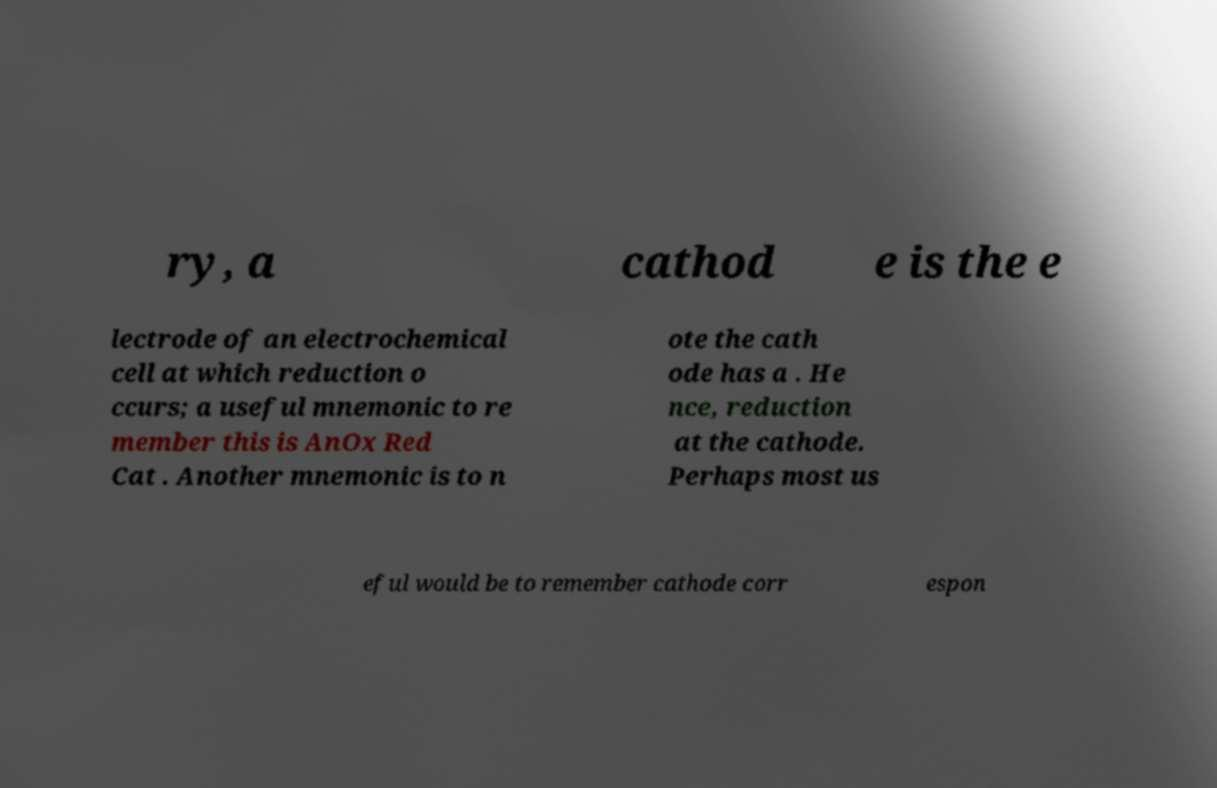What messages or text are displayed in this image? I need them in a readable, typed format. ry, a cathod e is the e lectrode of an electrochemical cell at which reduction o ccurs; a useful mnemonic to re member this is AnOx Red Cat . Another mnemonic is to n ote the cath ode has a . He nce, reduction at the cathode. Perhaps most us eful would be to remember cathode corr espon 